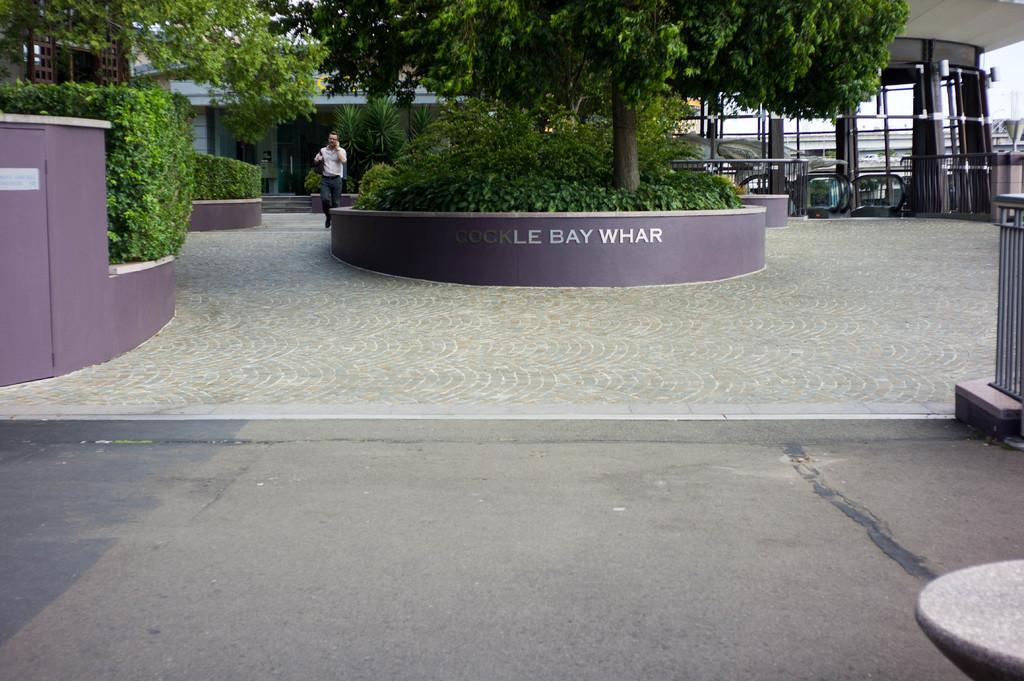How would you summarize this image in a sentence or two? In the foreground of this image, there is the road. In the background, there is the path, trees, plants, a man walking on the path and the building. 